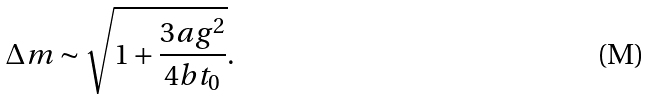<formula> <loc_0><loc_0><loc_500><loc_500>\Delta m \sim \sqrt { 1 + \frac { 3 a g ^ { 2 } } { 4 b t _ { 0 } } } .</formula> 